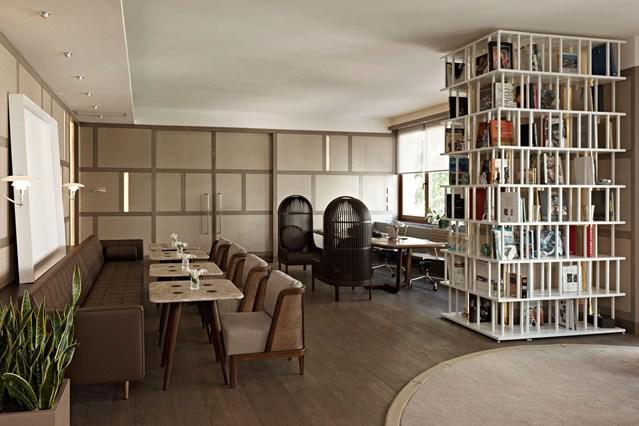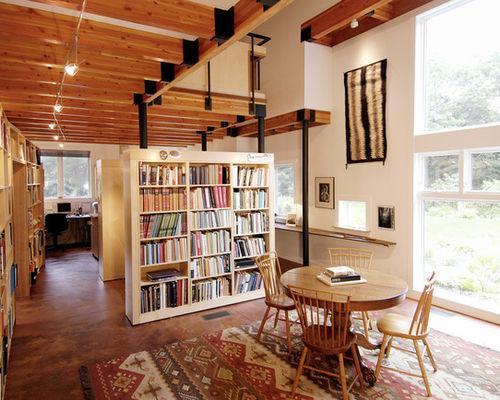The first image is the image on the left, the second image is the image on the right. Given the left and right images, does the statement "One image has a coffee table and couch in front of a book case." hold true? Answer yes or no. No. The first image is the image on the left, the second image is the image on the right. For the images displayed, is the sentence "Some of the shelving is white and a vase of pink flowers is on a sofa coffee table in one of the images." factually correct? Answer yes or no. No. 